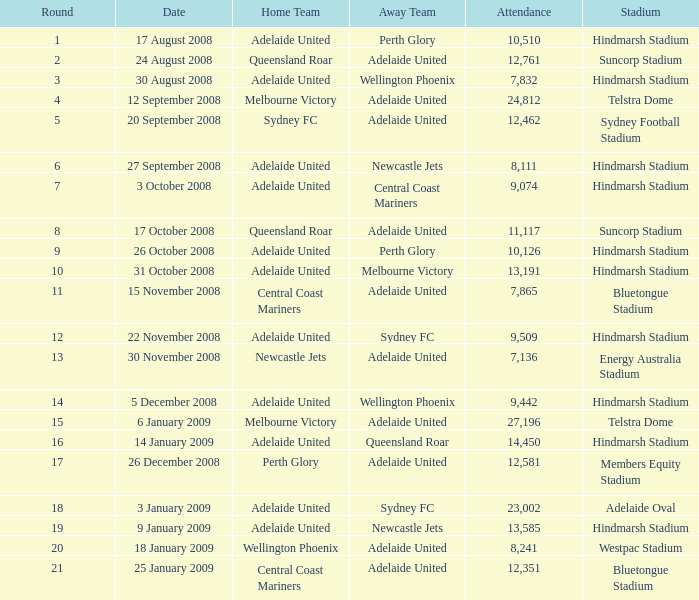In which round did 11,117 people attend the game on october 26, 2008? 9.0. 